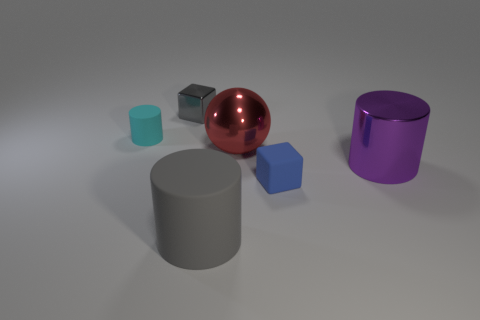Add 2 yellow things. How many objects exist? 8 Subtract all balls. How many objects are left? 5 Subtract 0 brown balls. How many objects are left? 6 Subtract all tiny shiny things. Subtract all big red objects. How many objects are left? 4 Add 3 purple cylinders. How many purple cylinders are left? 4 Add 4 small cubes. How many small cubes exist? 6 